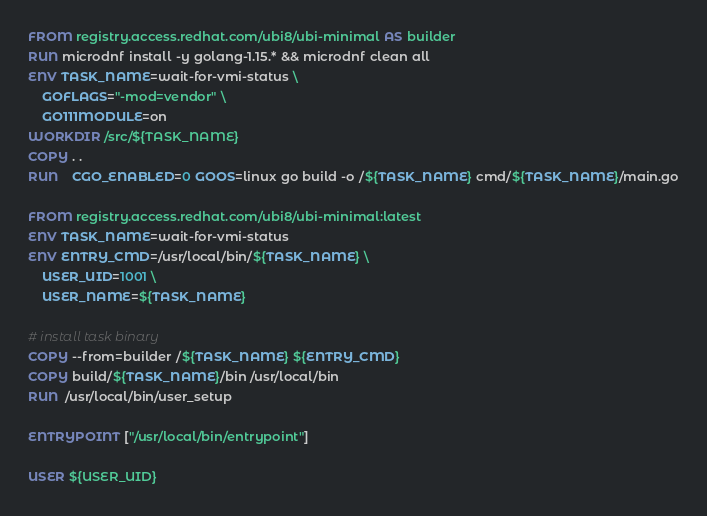<code> <loc_0><loc_0><loc_500><loc_500><_Dockerfile_>FROM registry.access.redhat.com/ubi8/ubi-minimal AS builder
RUN microdnf install -y golang-1.15.* && microdnf clean all
ENV TASK_NAME=wait-for-vmi-status \
    GOFLAGS="-mod=vendor" \
    GO111MODULE=on
WORKDIR /src/${TASK_NAME}
COPY . .
RUN	CGO_ENABLED=0 GOOS=linux go build -o /${TASK_NAME} cmd/${TASK_NAME}/main.go

FROM registry.access.redhat.com/ubi8/ubi-minimal:latest
ENV TASK_NAME=wait-for-vmi-status
ENV ENTRY_CMD=/usr/local/bin/${TASK_NAME} \
    USER_UID=1001 \
    USER_NAME=${TASK_NAME}

# install task binary
COPY --from=builder /${TASK_NAME} ${ENTRY_CMD}
COPY build/${TASK_NAME}/bin /usr/local/bin
RUN  /usr/local/bin/user_setup

ENTRYPOINT ["/usr/local/bin/entrypoint"]

USER ${USER_UID}
</code> 